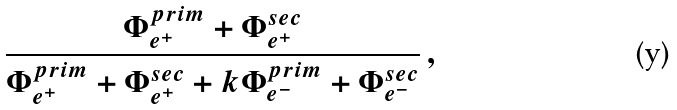<formula> <loc_0><loc_0><loc_500><loc_500>\frac { \Phi ^ { p r i m } _ { e ^ { + } } + \Phi ^ { s e c } _ { e ^ { + } } } { \Phi ^ { p r i m } _ { e ^ { + } } + \Phi ^ { s e c } _ { e ^ { + } } + k \Phi ^ { p r i m } _ { e ^ { - } } + \Phi ^ { s e c } _ { e ^ { - } } } \, ,</formula> 